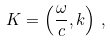Convert formula to latex. <formula><loc_0><loc_0><loc_500><loc_500>K = \left ( { \frac { \omega } { c } } , k \right ) \, ,</formula> 